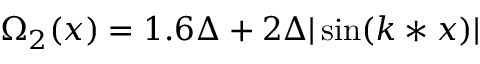Convert formula to latex. <formula><loc_0><loc_0><loc_500><loc_500>\Omega _ { 2 } ( x ) = 1 . 6 \Delta + 2 \Delta | \sin ( k * x ) |</formula> 